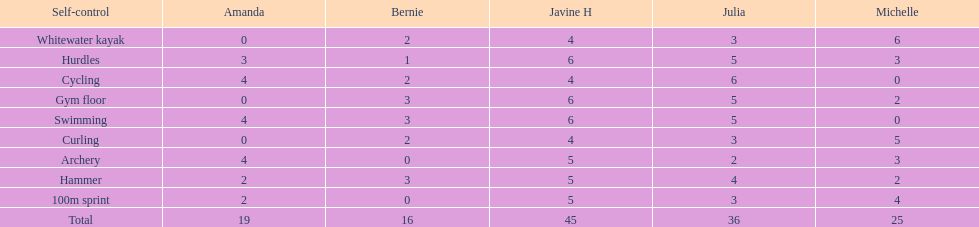Who scored the least on whitewater kayak? Amanda. 